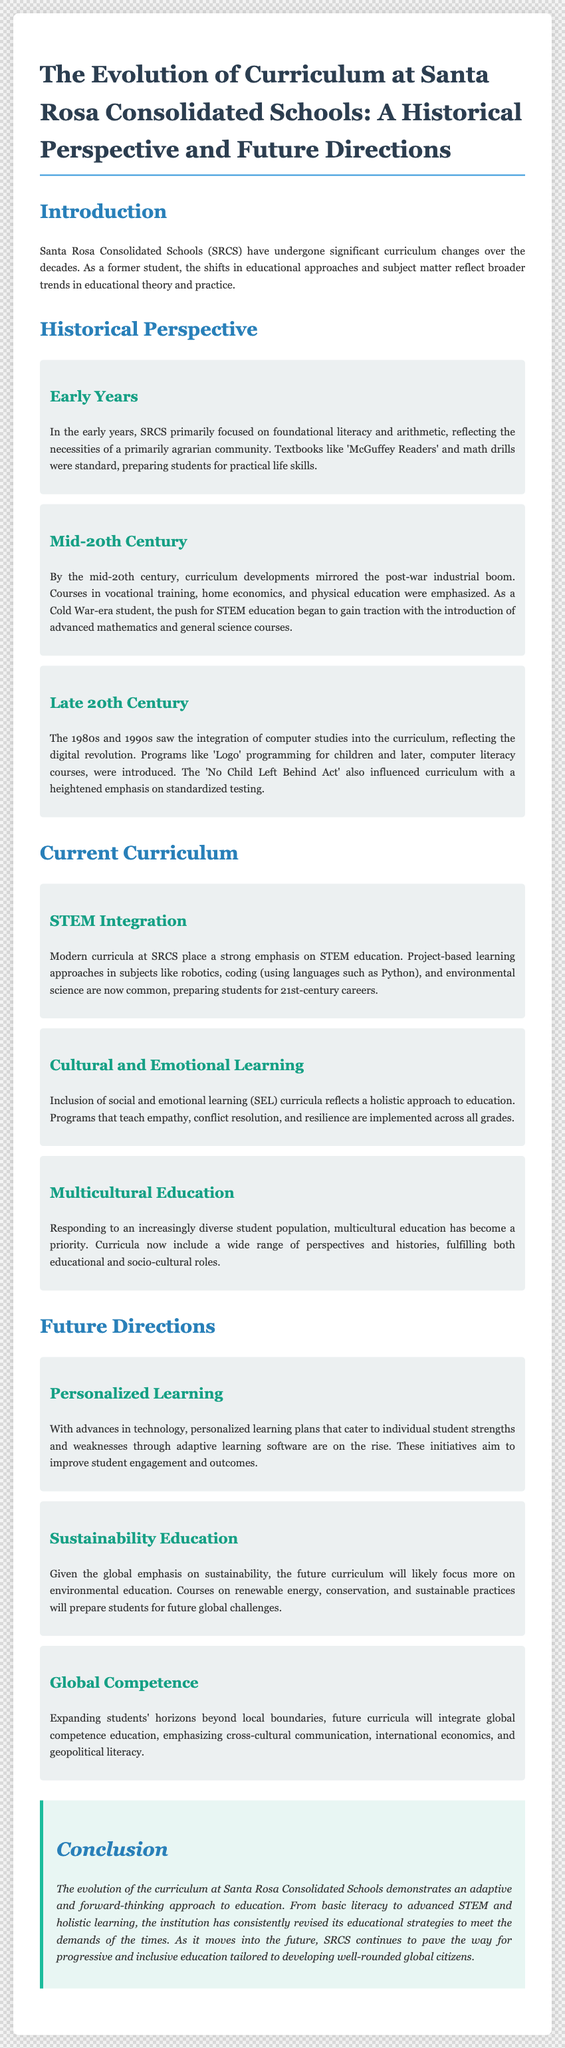What primary subjects did SRCS focus on in the early years? The document states that the early curriculum at SRCS primarily focused on foundational literacy and arithmetic.
Answer: Foundational literacy and arithmetic Which legislation influenced the curriculum in the late 20th century? The document mentions that the 'No Child Left Behind Act' influenced the curriculum during this period.
Answer: No Child Left Behind Act What is the emphasis of the current SRCS curriculum? The document highlights that modern curricula at SRCS place a strong emphasis on STEM education.
Answer: STEM education What type of learning is included in the current curriculum at SRCS? The document indicates that social and emotional learning (SEL) is included in the current curriculum.
Answer: Social and emotional learning Which programming language is mentioned in the current curriculum for coding? The document specifies that Python is one of the programming languages taught in coding classes.
Answer: Python What focus does the future curriculum have regarding environmental issues? According to the document, the future curriculum will likely focus more on sustainability education.
Answer: Sustainability education How many subsections are listed under the Historical Perspective section? The document contains three subsections under the Historical Perspective section.
Answer: Three What is the central theme of the conclusion in the document? The conclusion emphasizes the adaptive and forward-thinking approach to education at SRCS.
Answer: Adaptive and forward-thinking approach 